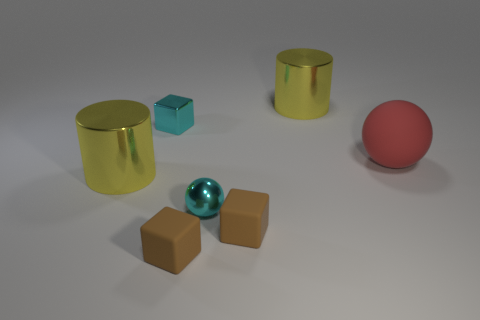Subtract all rubber blocks. How many blocks are left? 1 Add 3 yellow shiny things. How many objects exist? 10 Subtract all balls. How many objects are left? 5 Subtract 1 brown blocks. How many objects are left? 6 Subtract all brown matte cubes. Subtract all tiny brown rubber cubes. How many objects are left? 3 Add 5 brown objects. How many brown objects are left? 7 Add 4 brown shiny cubes. How many brown shiny cubes exist? 4 